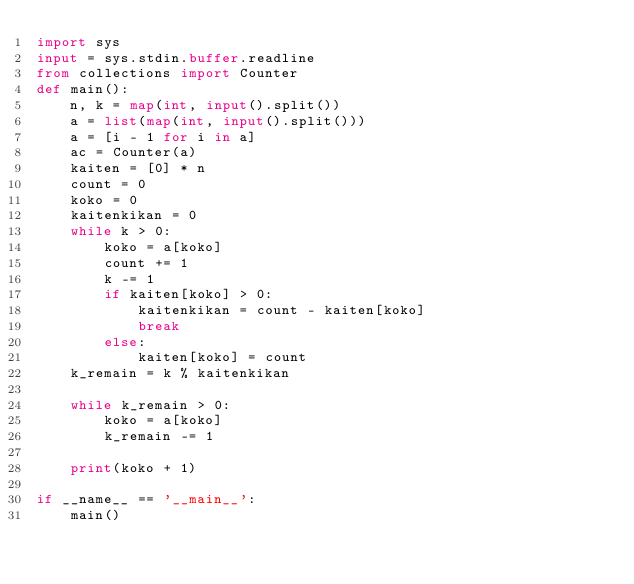Convert code to text. <code><loc_0><loc_0><loc_500><loc_500><_Python_>import sys
input = sys.stdin.buffer.readline
from collections import Counter
def main():
    n, k = map(int, input().split())
    a = list(map(int, input().split()))
    a = [i - 1 for i in a]
    ac = Counter(a)
    kaiten = [0] * n
    count = 0
    koko = 0
    kaitenkikan = 0
    while k > 0:
        koko = a[koko]
        count += 1
        k -= 1
        if kaiten[koko] > 0:
            kaitenkikan = count - kaiten[koko]
            break
        else:
            kaiten[koko] = count
    k_remain = k % kaitenkikan

    while k_remain > 0:
        koko = a[koko]
        k_remain -= 1

    print(koko + 1)

if __name__ == '__main__':
    main()</code> 